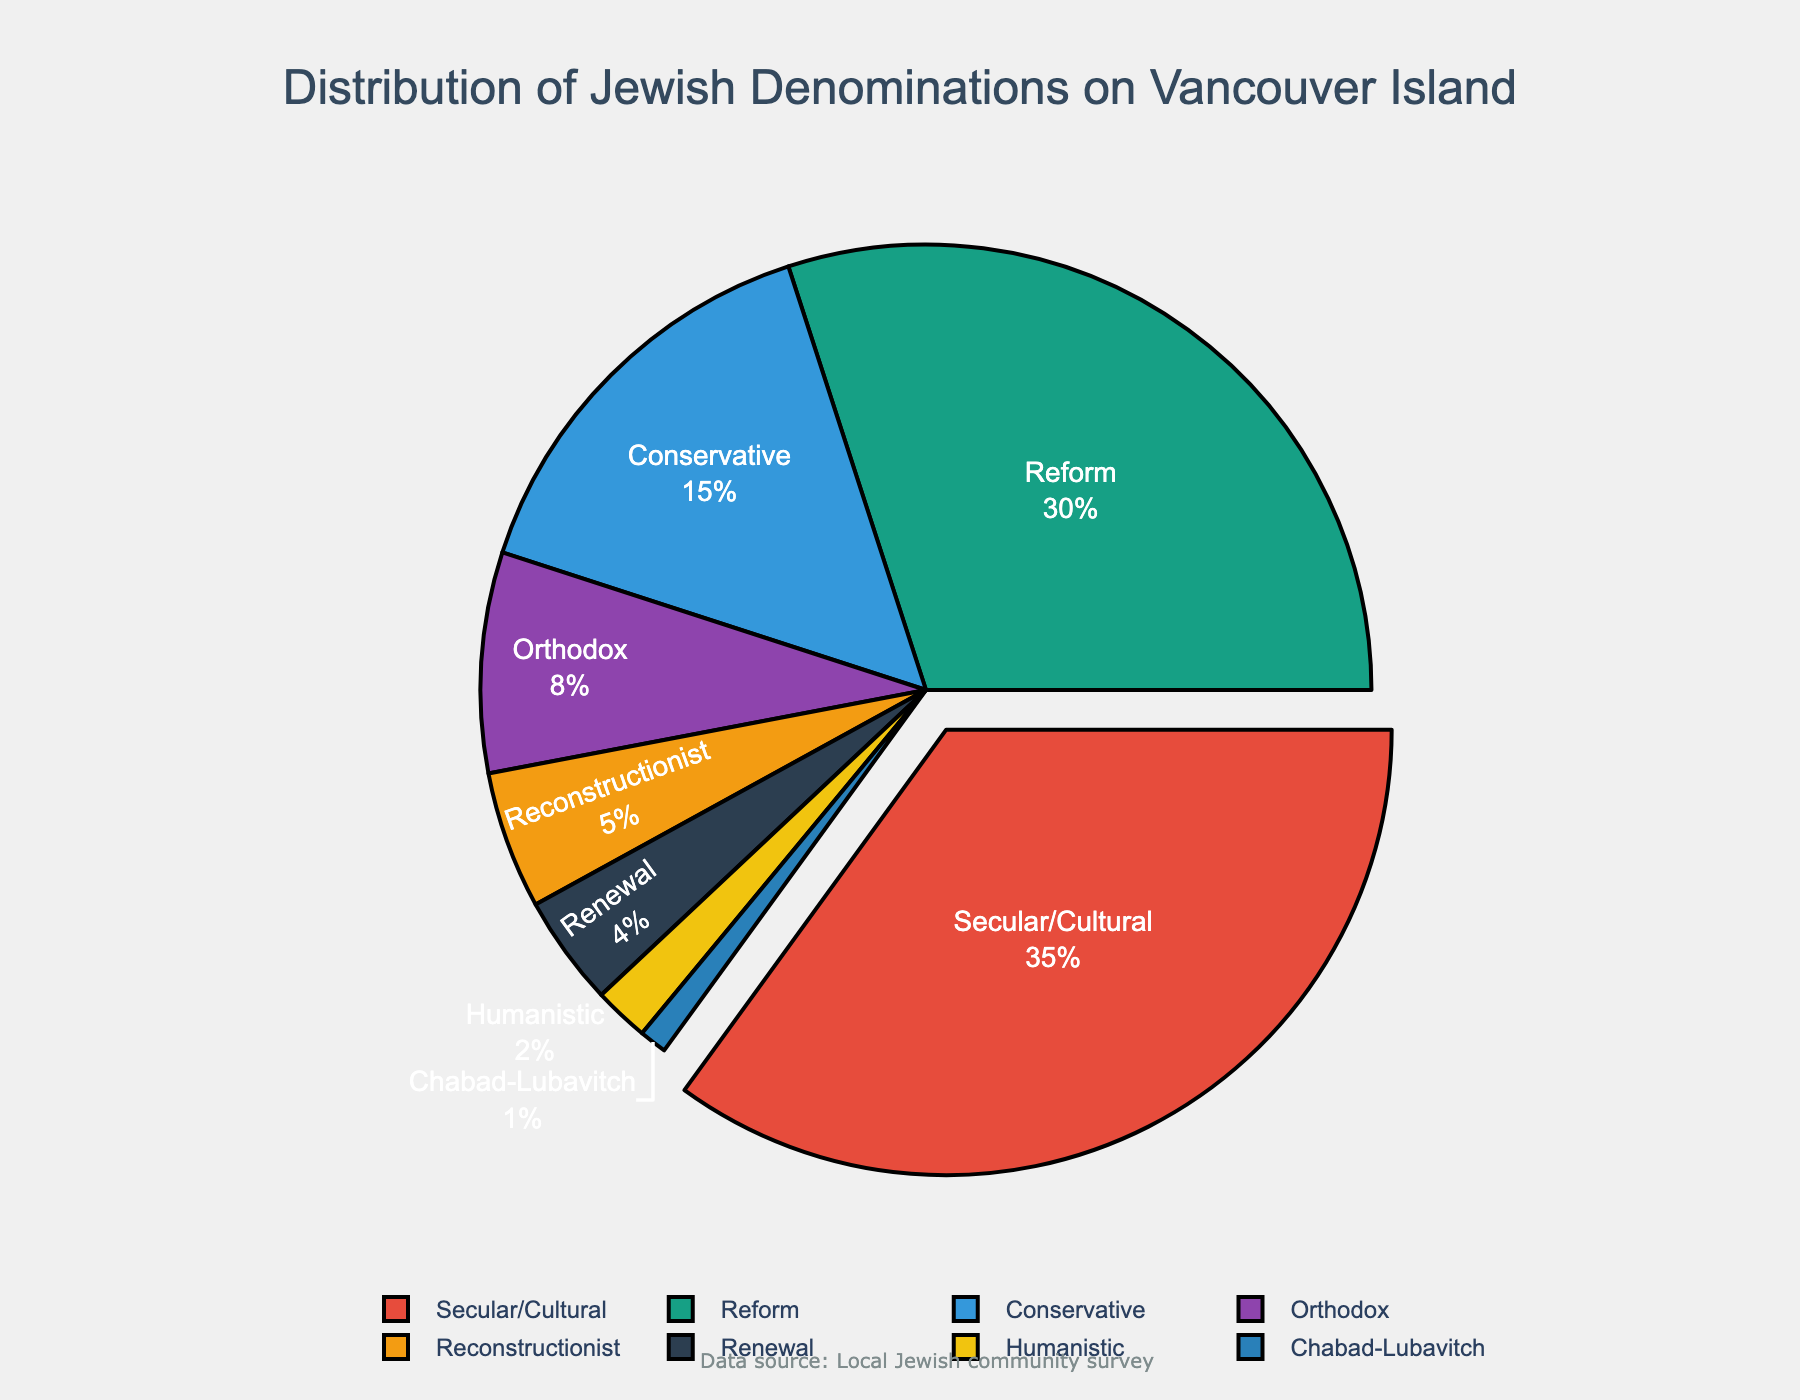what is the percentage difference between Reform and Orthodox denominations? To find the percentage difference, subtract the percentage of the Orthodox (8%) from the percentage of the Reform (30%).
Answer: 22% Which denomination has the smallest representation? The smallest representation is the denomination with the lowest percentage in the figure. That is Chabad-Lubavitch at 1%.
Answer: Chabad-Lubavitch Which denominations collectively cover more than half the population? Add the percentages of the denominations to see which add up to more than 50%. Secular/Cultural (35%) and Reform (30%) alone cover more than half.
Answer: Secular/Cultural and Reform What is the combined percentage of Conservative and Reconstructionist groups? Sum the percentages of Conservative (15%) and Reconstructionist (5%). 15 + 5 = 20%.
Answer: 20% Which denomination's percentage is highlighted by being pulled out from the pie chart? The figure pulls out the denomination with the highest percentage. The highest percentage is 35%, which corresponds to Secular/Cultural.
Answer: Secular/Cultural How does the Renewal percentage compare with the Humanistic percentage? Renewal has a percentage of 4%, whereas Humanistic has 2%. Renewal is double the percentage of Humanistic.
Answer: Renewal is double Humanistic What is the visual representation color for the Conservative denomination? The chart uses specific colors for each denomination. Conservative's color can be checked visually in the figure.
Answer: Blue Is the percentage of Reform greater than the percentage of Orthodox, Conservative, and Reconstructionist combined? Compare the percentage of Reform (30%) with the sum of Orthodox (8%), Conservative (15%), and Reconstructionist (5%). 8 + 15 + 5 = 28%, which is less than 30%.
Answer: Yes Which groups cumulatively make up one-fifth of the population? One-fifth is 20%. The groups Humanistic (2%) and Chabad-Lubavitch (1%) sum to 3%, adding to the Renewal (4%) makes 7%, and adding Reconstructionist (5%), it makes 12%. Adding Orthodox (8%) finally makes 20%. Thus, Humanistic, Chabad-Lubavitch, Renewal, Reconstructionist, and Orthodox collectively make up one-fifth.
Answer: Humanistic, Chabad-Lubavitch, Renewal, Reconstructionist, and Orthodox 